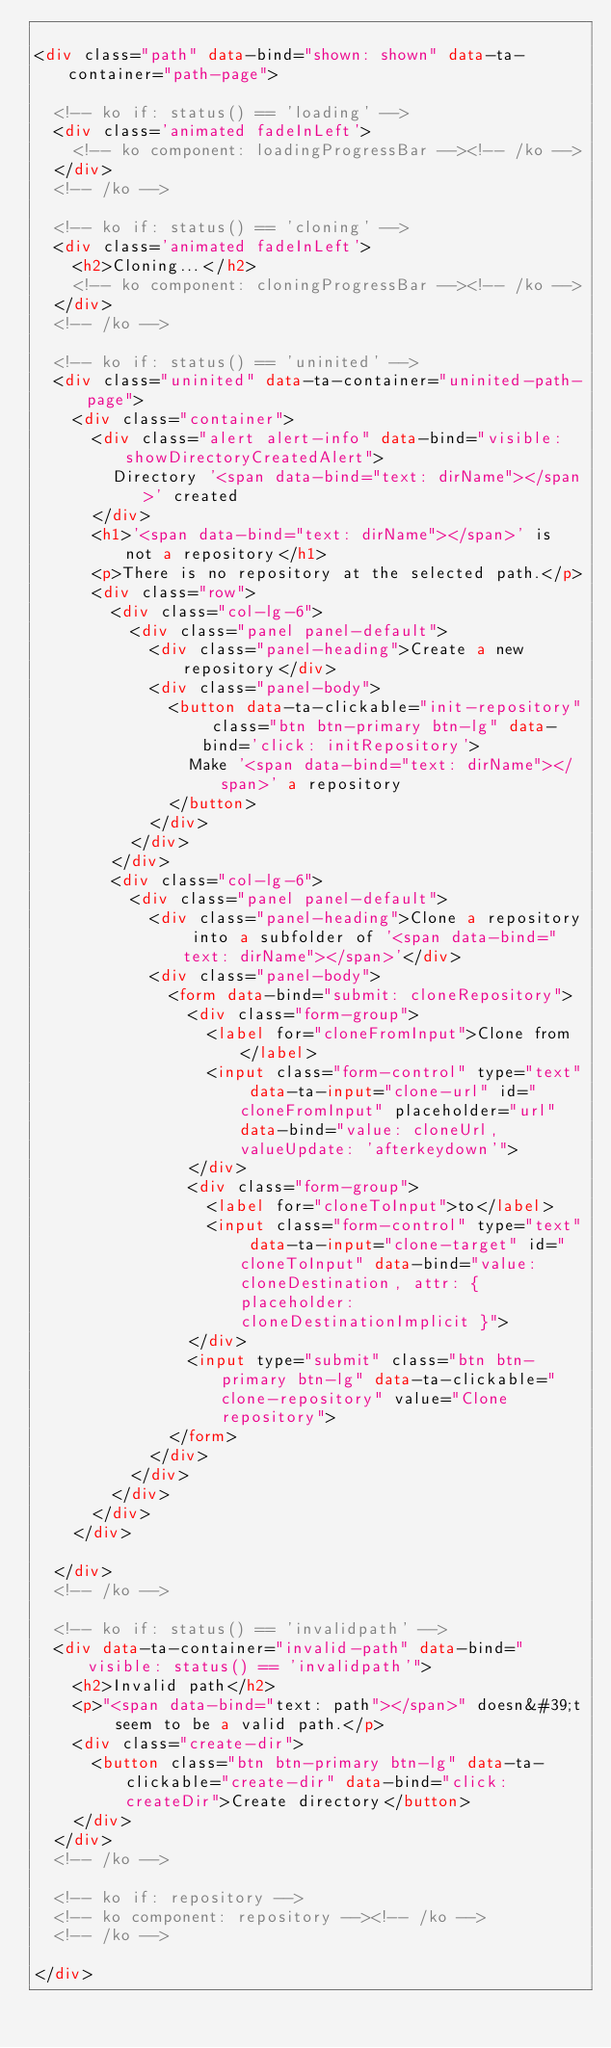Convert code to text. <code><loc_0><loc_0><loc_500><loc_500><_HTML_>
<div class="path" data-bind="shown: shown" data-ta-container="path-page">

  <!-- ko if: status() == 'loading' -->
  <div class='animated fadeInLeft'>
    <!-- ko component: loadingProgressBar --><!-- /ko -->
  </div>
  <!-- /ko -->

  <!-- ko if: status() == 'cloning' -->
  <div class='animated fadeInLeft'>
    <h2>Cloning...</h2>
    <!-- ko component: cloningProgressBar --><!-- /ko -->
  </div>
  <!-- /ko -->
  
  <!-- ko if: status() == 'uninited' -->
  <div class="uninited" data-ta-container="uninited-path-page">
    <div class="container">
      <div class="alert alert-info" data-bind="visible: showDirectoryCreatedAlert">
        Directory '<span data-bind="text: dirName"></span>' created
      </div>
      <h1>'<span data-bind="text: dirName"></span>' is not a repository</h1>
      <p>There is no repository at the selected path.</p>
      <div class="row">
        <div class="col-lg-6">
          <div class="panel panel-default">
            <div class="panel-heading">Create a new repository</div>
            <div class="panel-body">
              <button data-ta-clickable="init-repository" class="btn btn-primary btn-lg" data-bind='click: initRepository'>
                Make '<span data-bind="text: dirName"></span>' a repository
              </button>
            </div>
          </div>
        </div>
        <div class="col-lg-6">
          <div class="panel panel-default">
            <div class="panel-heading">Clone a repository into a subfolder of '<span data-bind="text: dirName"></span>'</div>
            <div class="panel-body">
              <form data-bind="submit: cloneRepository">
                <div class="form-group">
                  <label for="cloneFromInput">Clone from</label>
                  <input class="form-control" type="text" data-ta-input="clone-url" id="cloneFromInput" placeholder="url" data-bind="value: cloneUrl, valueUpdate: 'afterkeydown'">
                </div>
                <div class="form-group">
                  <label for="cloneToInput">to</label>
                  <input class="form-control" type="text" data-ta-input="clone-target" id="cloneToInput" data-bind="value: cloneDestination, attr: { placeholder: cloneDestinationImplicit }">
                </div>
                <input type="submit" class="btn btn-primary btn-lg" data-ta-clickable="clone-repository" value="Clone repository">
              </form>
            </div>
          </div>
        </div>
      </div>
    </div>
    
  </div>
  <!-- /ko -->

  <!-- ko if: status() == 'invalidpath' -->
  <div data-ta-container="invalid-path" data-bind="visible: status() == 'invalidpath'">
    <h2>Invalid path</h2>
    <p>"<span data-bind="text: path"></span>" doesn&#39;t seem to be a valid path.</p>
    <div class="create-dir">
      <button class="btn btn-primary btn-lg" data-ta-clickable="create-dir" data-bind="click: createDir">Create directory</button>
    </div>
  </div>
  <!-- /ko -->

  <!-- ko if: repository -->
  <!-- ko component: repository --><!-- /ko -->
  <!-- /ko -->

</div></code> 